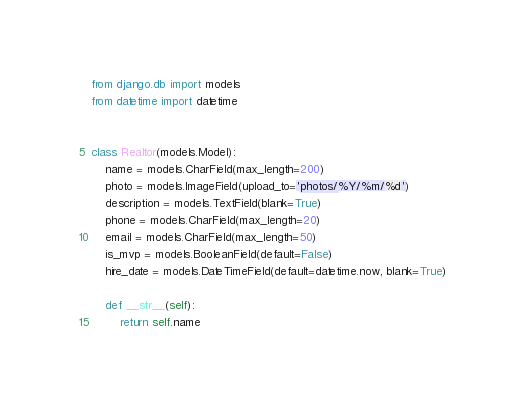<code> <loc_0><loc_0><loc_500><loc_500><_Python_>from django.db import models
from datetime import datetime


class Realtor(models.Model):
    name = models.CharField(max_length=200)
    photo = models.ImageField(upload_to='photos/%Y/%m/%d')
    description = models.TextField(blank=True)
    phone = models.CharField(max_length=20)
    email = models.CharField(max_length=50)
    is_mvp = models.BooleanField(default=False)
    hire_date = models.DateTimeField(default=datetime.now, blank=True)

    def __str__(self):
        return self.name
</code> 